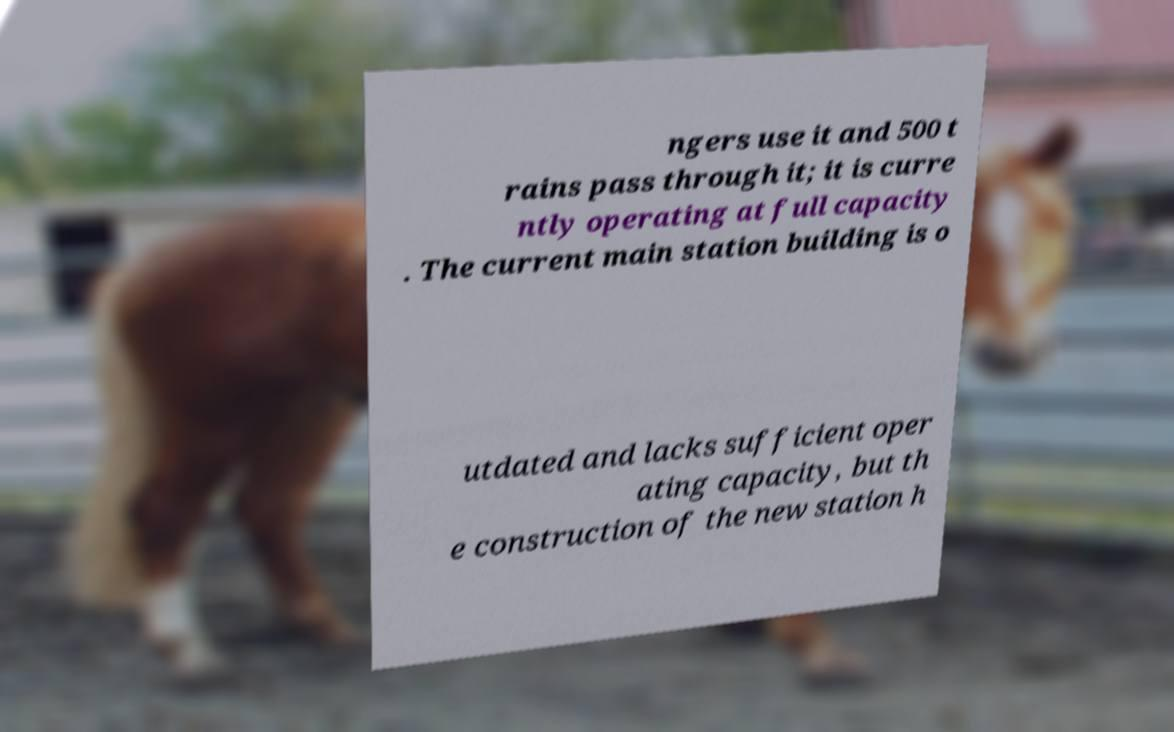For documentation purposes, I need the text within this image transcribed. Could you provide that? ngers use it and 500 t rains pass through it; it is curre ntly operating at full capacity . The current main station building is o utdated and lacks sufficient oper ating capacity, but th e construction of the new station h 